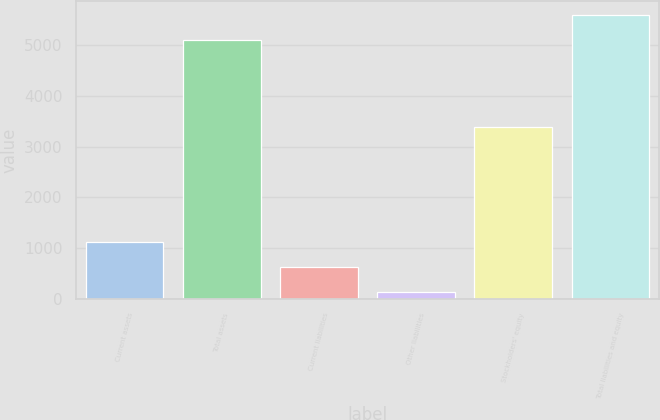Convert chart. <chart><loc_0><loc_0><loc_500><loc_500><bar_chart><fcel>Current assets<fcel>Total assets<fcel>Current liabilities<fcel>Other liabilities<fcel>Stockholders' equity<fcel>Total liabilities and equity<nl><fcel>1130.6<fcel>5086.6<fcel>636.1<fcel>141.6<fcel>3382.9<fcel>5581.1<nl></chart> 